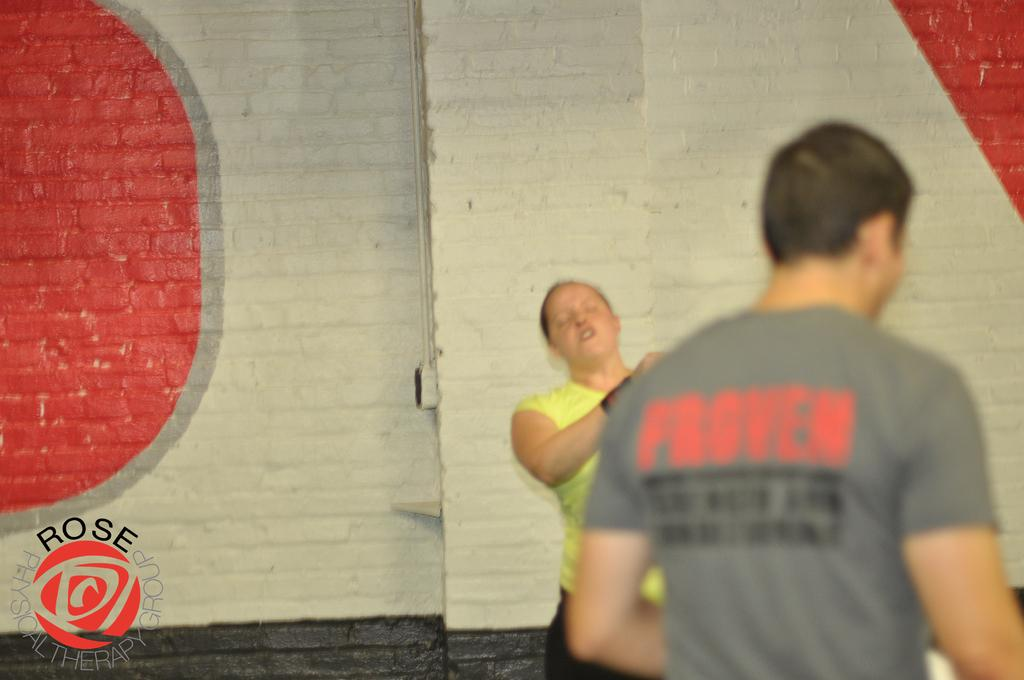What is the gender of the person in the image? There is a man in the image. What is the man wearing in the image? The man is wearing a gray T-shirt. Are there any other people in the image? Yes, there is a woman in the image. What is the woman wearing in the image? The woman is wearing a green T-shirt and black pants. What can be seen in the background of the image? There is a wall in the background of the image. Can you describe the thickness of the fog in the image? There is no fog present in the image. What type of cloth is the woman using to cover her knee in the image? There is no cloth covering the woman's knee in the image, and there is no mention of fog or any other weather-related elements. 